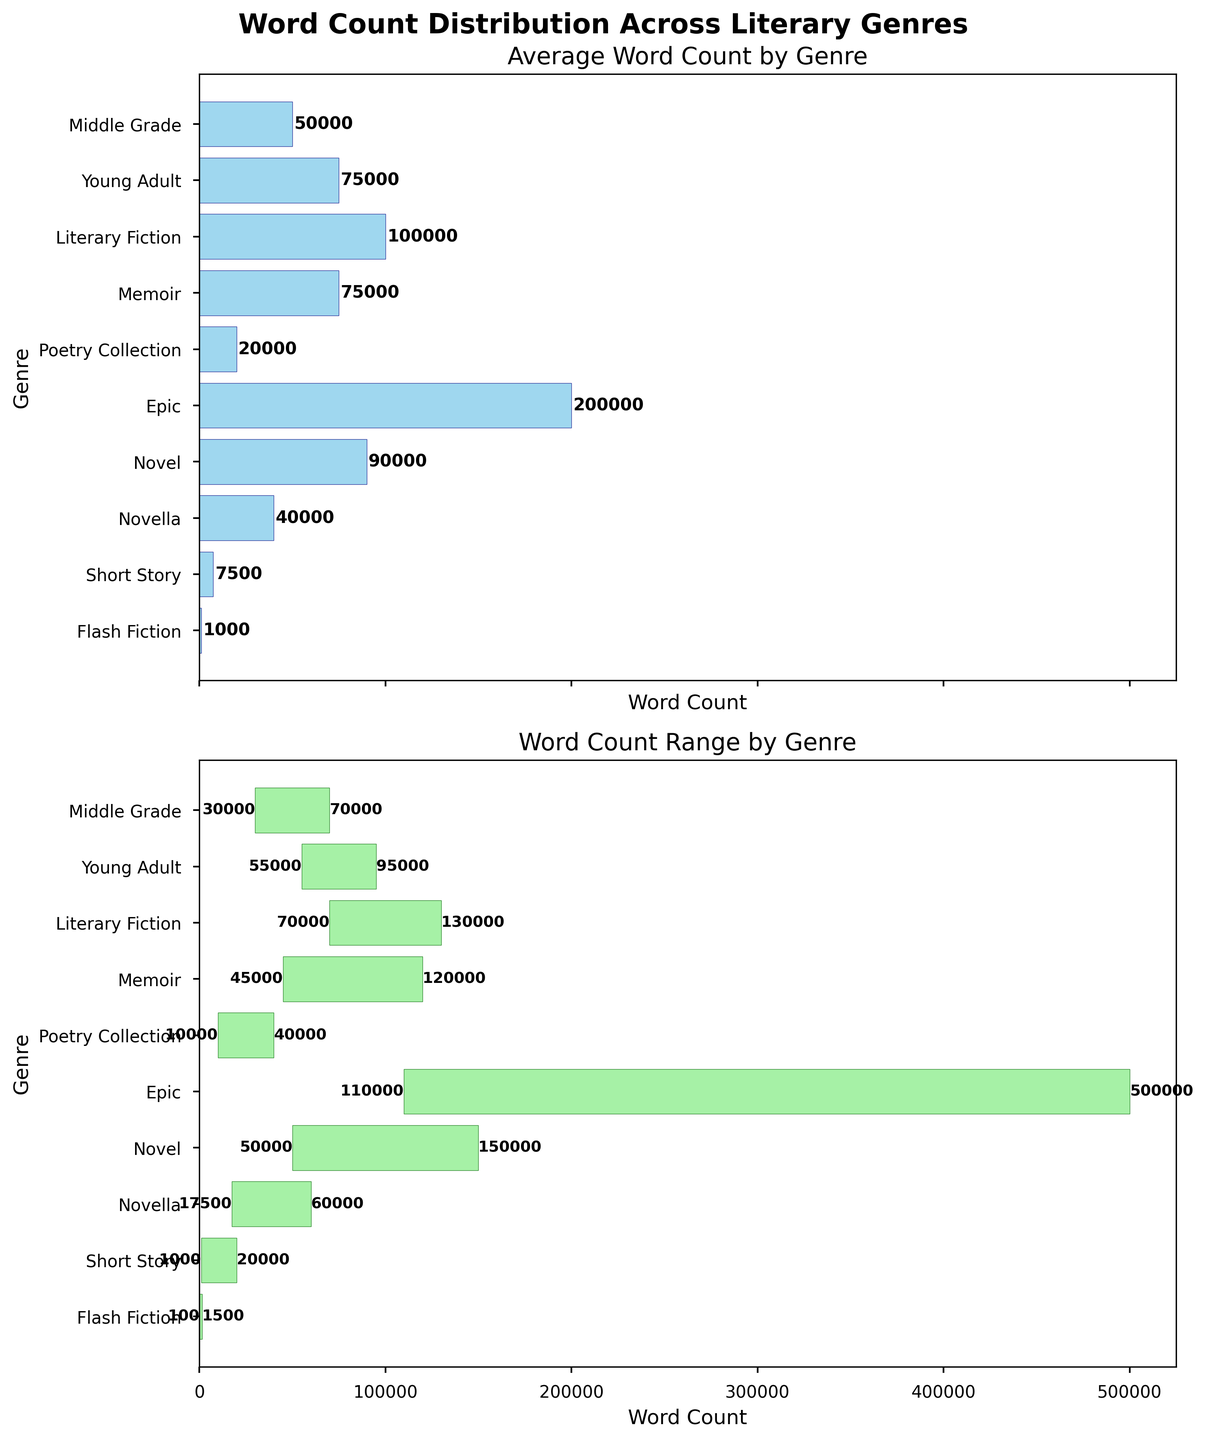What is the title of the figure? The title of the figure is written in bold at the top of the plots. It reads "Word Count Distribution Across Literary Genres".
Answer: Word Count Distribution Across Literary Genres Which genre has the highest average word count? From the first subplot, the tallest bar corresponds to the "Epic" genre, which indicates the highest average word count.
Answer: Epic What is the average word count for a Memoir? In the first subplot, the bar for "Memoir" has a label that reads "75000", indicating its average word count.
Answer: 75000 What is the minimum word count for a Novel? The second subplot shows the range for "Novel", starting at the minimum value labeled "50000".
Answer: 50000 How do the average word counts of a Novella and Young Adult compare? In the first subplot, the bars for "Novella" and "Young Adult" show average word counts of 40000 and 75000, respectively. "Young Adult" has a higher average word count than "Novella".
Answer: Young Adult has a higher average What is the maximum word count for the Epic genre? The second subplot shows the range for "Epic", ending at the maximum value labeled "500000".
Answer: 500000 Considering both subplots, which genre has the smallest range of word counts? In the second subplot, the range is represented by the length of the bar. "Flash Fiction" has one of the smallest ranges, between 100 and 1500, a difference of 1400, smaller than other genres.
Answer: Flash Fiction Which genres have an average word count higher than 100,000? Using the first subplot, the bars with average word counts greater than 100,000 are "Epic" and "Literary Fiction".
Answer: Epic, Literary Fiction How much higher is the maximum word count of Literary Fiction compared to Middle Grade? From the second subplot, the maximum word count for "Literary Fiction" is 130000 and for "Middle Grade" is 70000. The difference is 130000 - 70000 = 60000.
Answer: 60000 What is the range of word counts for Poetry Collection and how does it compare to Memoir? The second subplot shows the range for "Poetry Collection" as 10000 to 40000 (a range of 30000) and for "Memoir" as 45000 to 120000 (a range of 75000). "Poetry Collection" has a smaller range than "Memoir".
Answer: Poetry Collection has a smaller range 